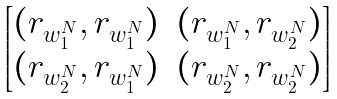Convert formula to latex. <formula><loc_0><loc_0><loc_500><loc_500>\begin{bmatrix} ( r _ { w _ { 1 } ^ { N } } , r _ { w _ { 1 } ^ { N } } ) & ( r _ { w _ { 1 } ^ { N } } , r _ { w _ { 2 } ^ { N } } ) \\ ( r _ { w _ { 2 } ^ { N } } , r _ { w _ { 1 } ^ { N } } ) & ( r _ { w _ { 2 } ^ { N } } , r _ { w _ { 2 } ^ { N } } ) \end{bmatrix}</formula> 